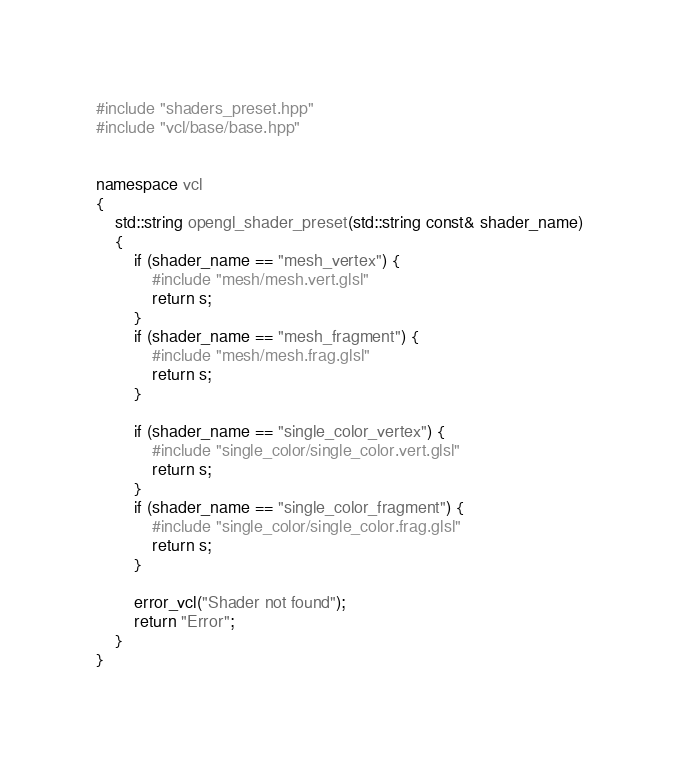<code> <loc_0><loc_0><loc_500><loc_500><_C++_>#include "shaders_preset.hpp"
#include "vcl/base/base.hpp"


namespace vcl
{
	std::string opengl_shader_preset(std::string const& shader_name)
	{
		if (shader_name == "mesh_vertex") {
			#include "mesh/mesh.vert.glsl"
			return s;
		}
		if (shader_name == "mesh_fragment") {
			#include "mesh/mesh.frag.glsl"
			return s;
		}

		if (shader_name == "single_color_vertex") {
			#include "single_color/single_color.vert.glsl"
			return s;
		}
		if (shader_name == "single_color_fragment") {
			#include "single_color/single_color.frag.glsl"
			return s;
		}

		error_vcl("Shader not found");
		return "Error";
	}
}</code> 